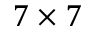Convert formula to latex. <formula><loc_0><loc_0><loc_500><loc_500>7 \times 7</formula> 